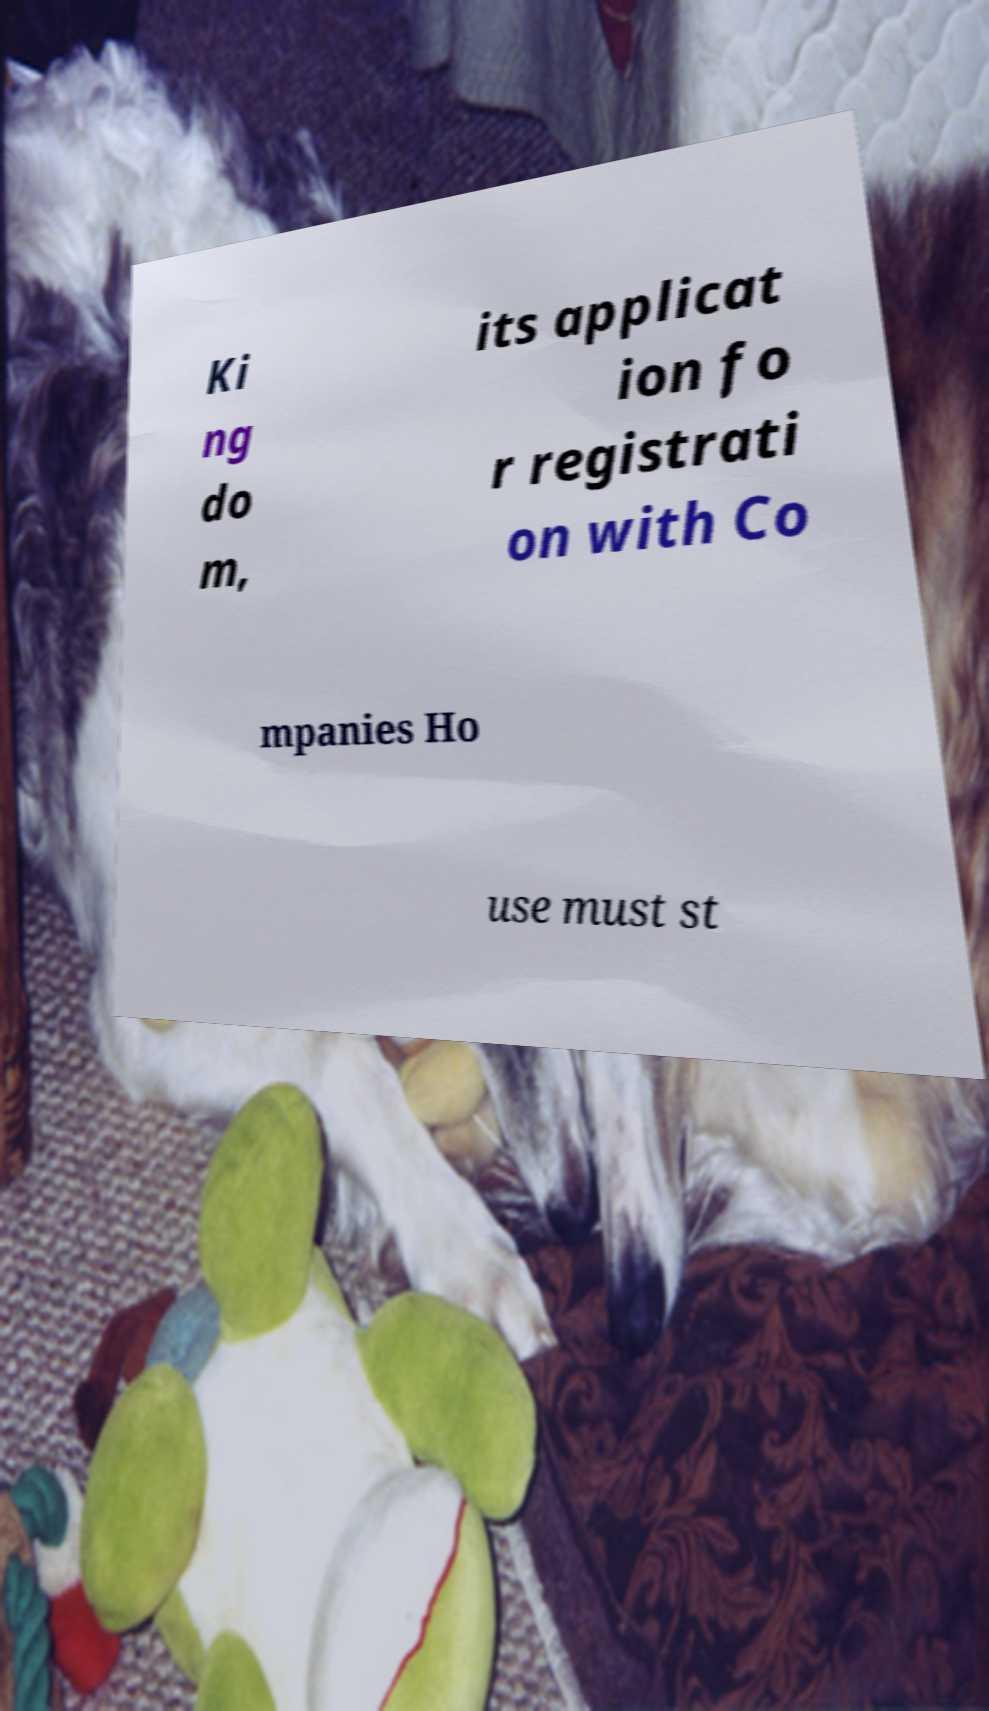I need the written content from this picture converted into text. Can you do that? Ki ng do m, its applicat ion fo r registrati on with Co mpanies Ho use must st 